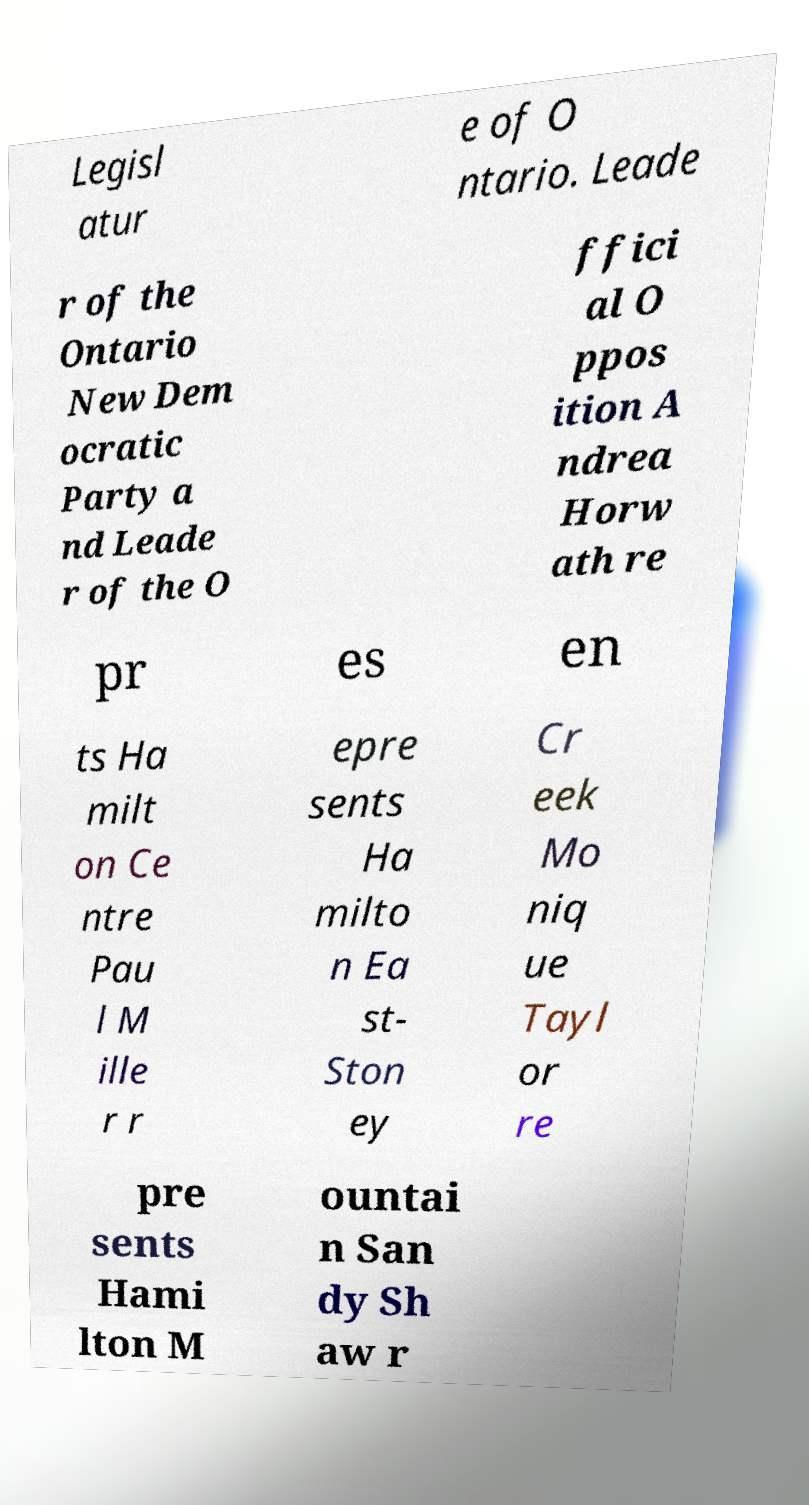There's text embedded in this image that I need extracted. Can you transcribe it verbatim? Legisl atur e of O ntario. Leade r of the Ontario New Dem ocratic Party a nd Leade r of the O ffici al O ppos ition A ndrea Horw ath re pr es en ts Ha milt on Ce ntre Pau l M ille r r epre sents Ha milto n Ea st- Ston ey Cr eek Mo niq ue Tayl or re pre sents Hami lton M ountai n San dy Sh aw r 